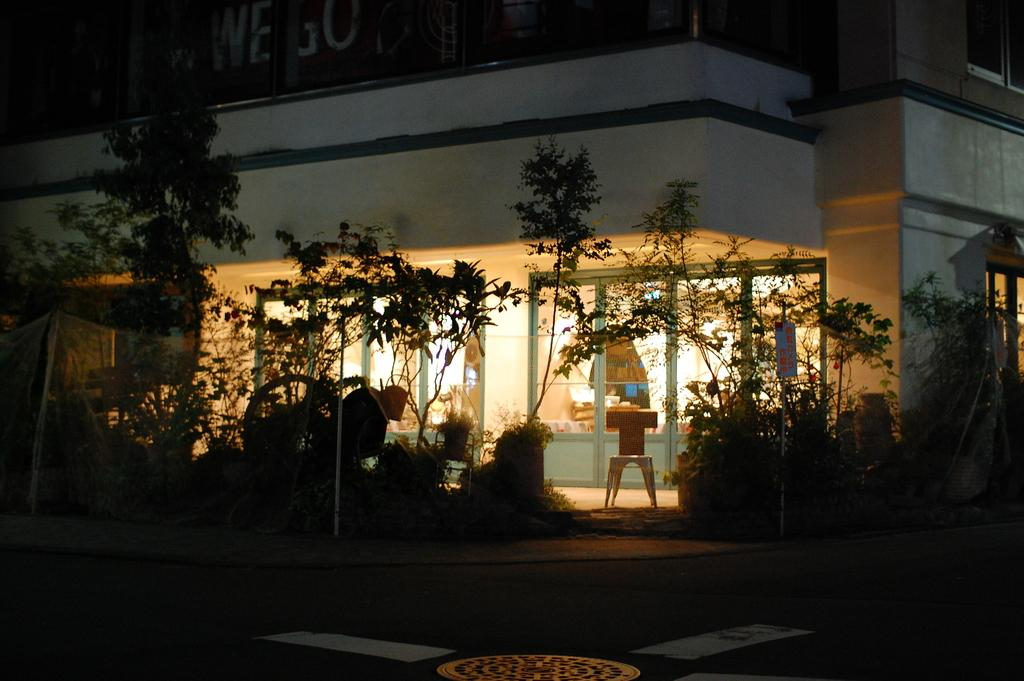What type of natural elements can be seen in the image? There are trees and plants in the image. What type of structure is present in the image? There is a house in the image. What architectural features can be seen on the house? There are doors visible in the image. What type of wall is present in the house? There is a framed glass wall in the image. Can you see any fairies flying around the trees in the image? There are no fairies present in the image; it only features trees, plants, a house, doors, and a framed glass wall. What type of can is visible in the image? There is no can present in the image. 